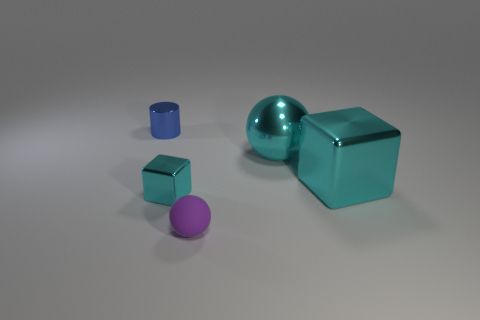What number of objects are behind the tiny cyan metallic object and on the right side of the blue metallic cylinder?
Give a very brief answer. 2. How many objects are either things on the right side of the big cyan metal ball or cyan cubes to the right of the large cyan metal ball?
Ensure brevity in your answer.  1. What number of other objects are there of the same size as the cyan metallic sphere?
Keep it short and to the point. 1. There is a metallic thing on the left side of the cube to the left of the purple object; what shape is it?
Your answer should be compact. Cylinder. Is the color of the block right of the cyan ball the same as the object left of the tiny cube?
Your answer should be very brief. No. Is there any other thing that has the same color as the tiny sphere?
Offer a terse response. No. The tiny rubber sphere is what color?
Offer a terse response. Purple. Is there a cyan thing?
Offer a terse response. Yes. Are there any metallic spheres behind the big cyan metallic block?
Offer a terse response. Yes. What material is the other big object that is the same shape as the purple thing?
Offer a terse response. Metal. 